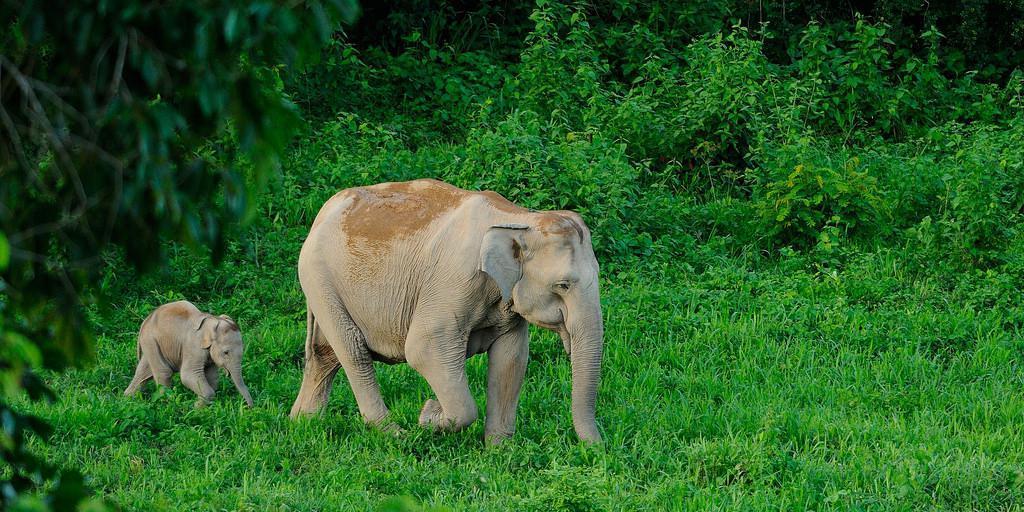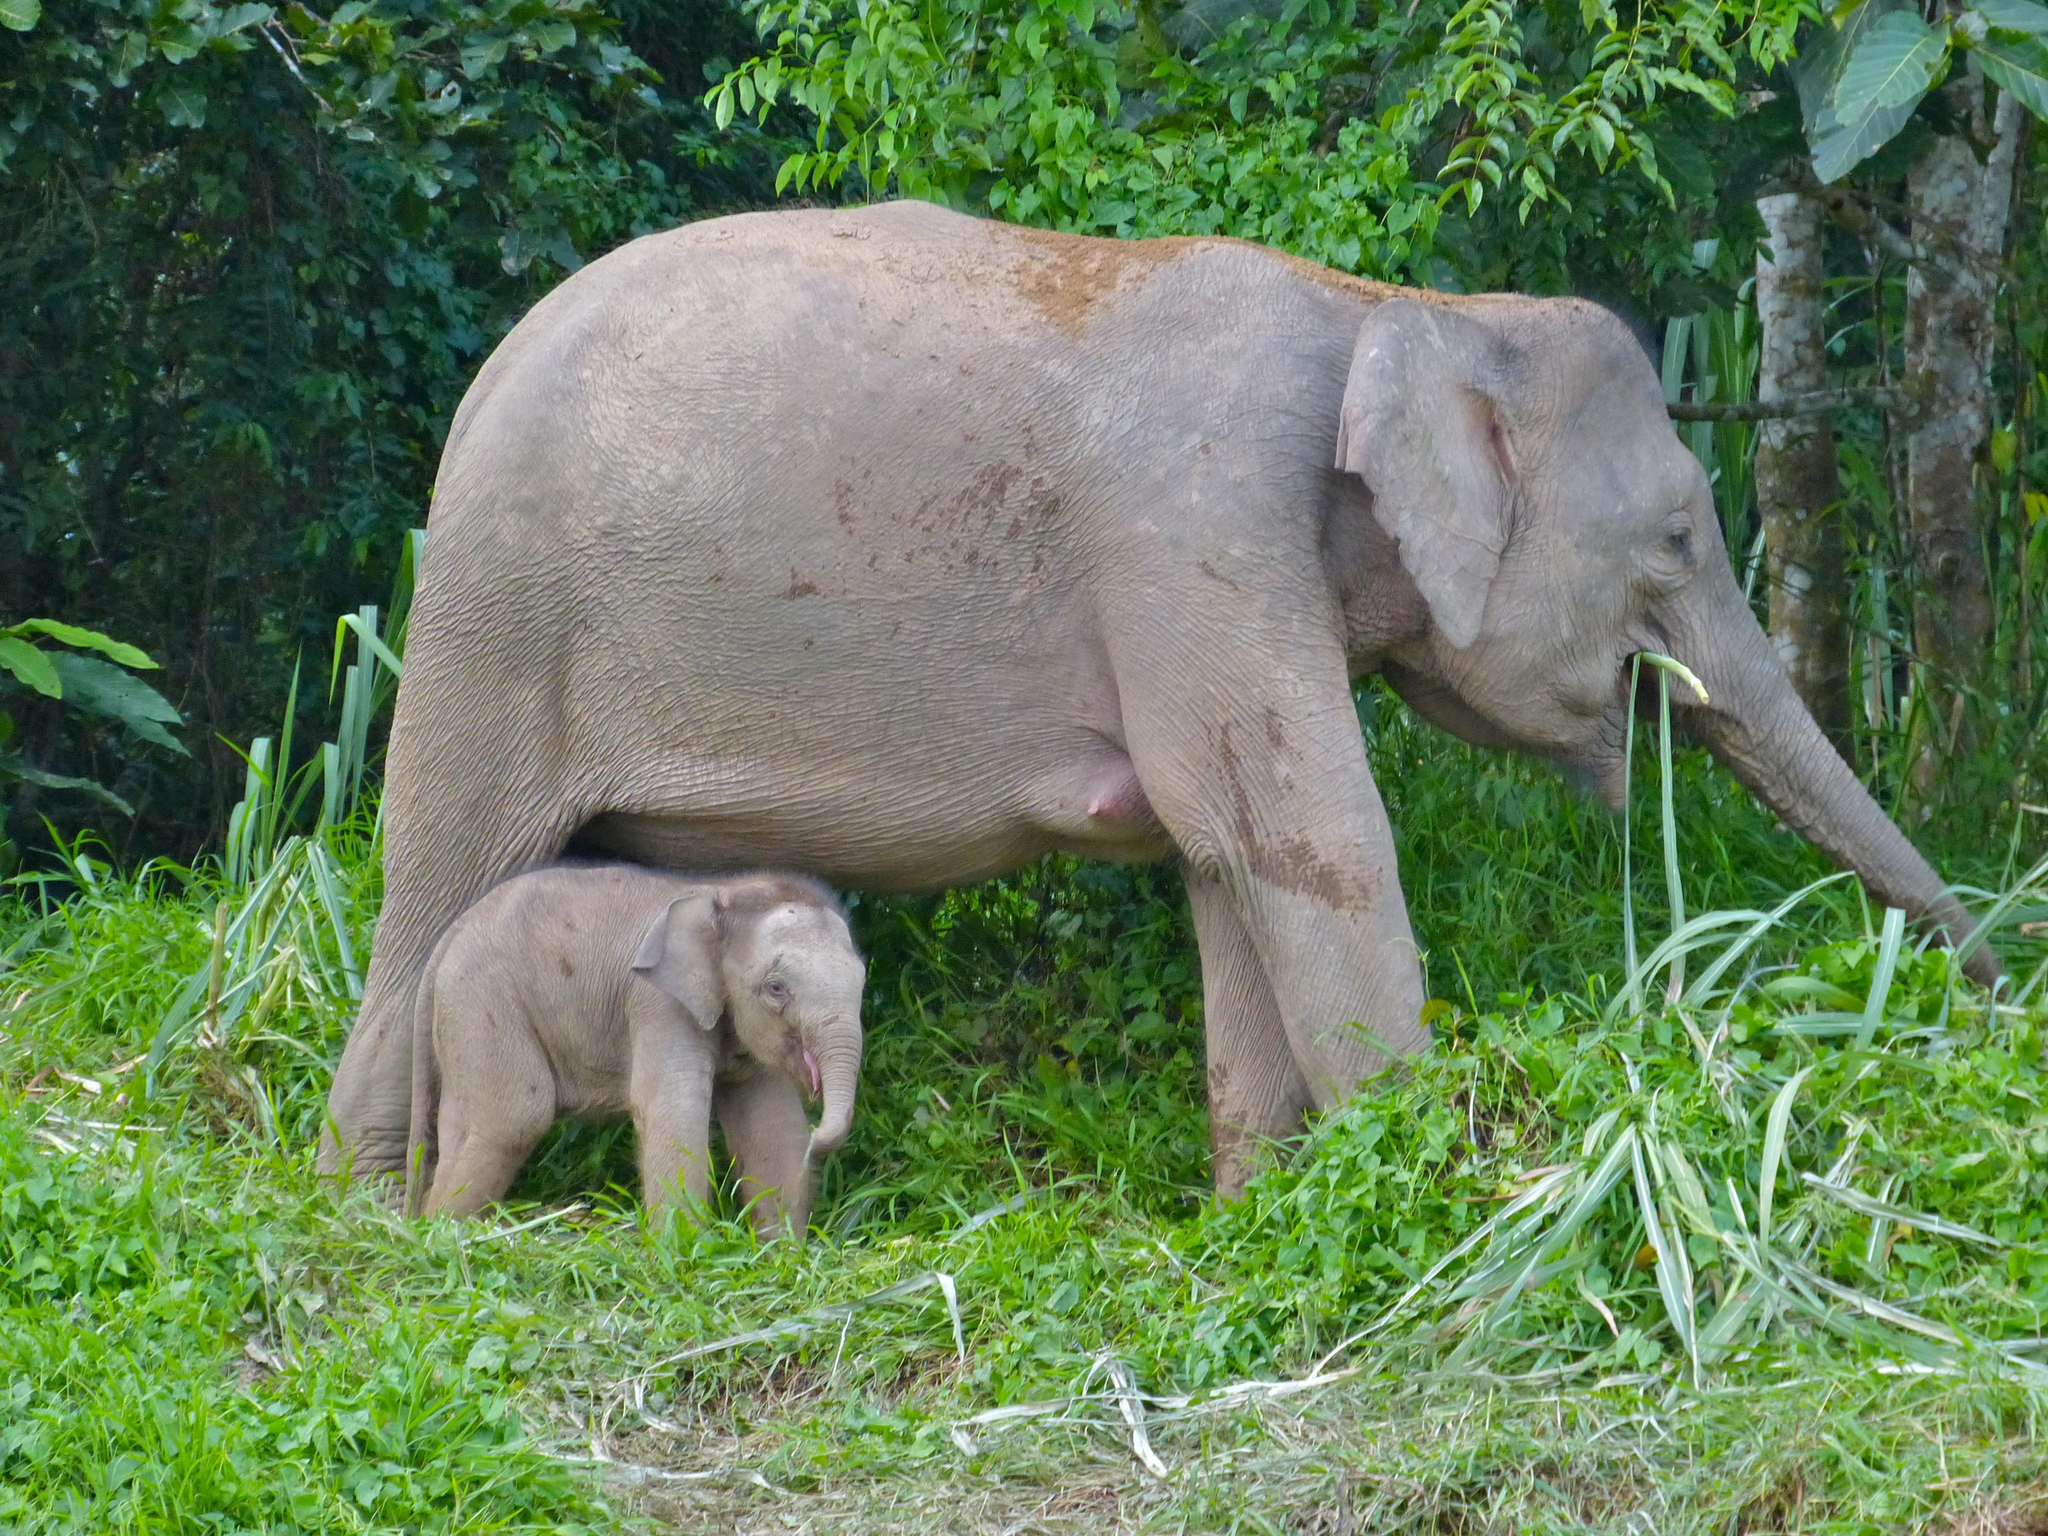The first image is the image on the left, the second image is the image on the right. Considering the images on both sides, is "A water hole is present in a scene with multiple elephants of different ages." valid? Answer yes or no. No. The first image is the image on the left, the second image is the image on the right. Considering the images on both sides, is "Elephants are standing in or beside water in the right image." valid? Answer yes or no. No. 